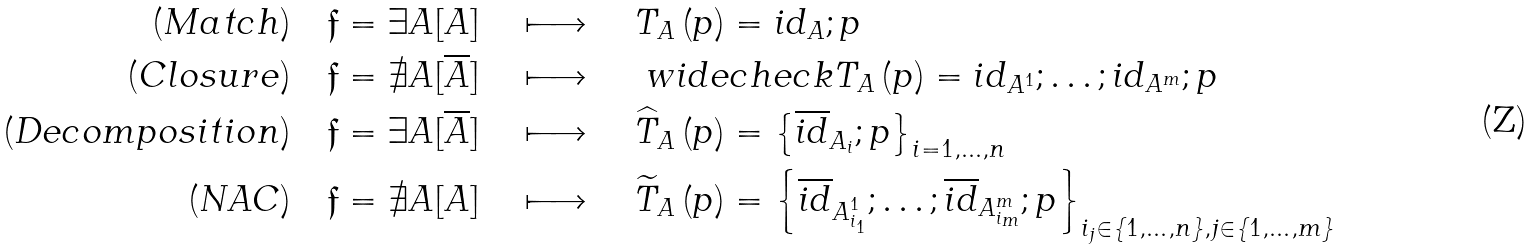<formula> <loc_0><loc_0><loc_500><loc_500>( M a t c h ) \quad \mathfrak { f } & = \exists A [ A ] \quad \longmapsto \quad T _ { A } \left ( p \right ) = i d _ { A } ; p \\ ( C l o s u r e ) \quad \mathfrak { f } & = \nexists A [ \overline { A } ] \quad \longmapsto \quad \ w i d e c h e c k { T } _ { A } \left ( p \right ) = i d _ { A ^ { 1 } } ; \dots ; i d _ { A ^ { m } } ; p \\ ( D e c o m p o s i t i o n ) \quad \mathfrak { f } & = \exists A [ \overline { A } ] \quad \longmapsto \quad \widehat { T } _ { A } \left ( p \right ) = \left \{ \overline { i d } _ { A _ { i } } ; p \right \} _ { i = 1 , \dots , n } \\ ( N A C ) \quad \mathfrak { f } & = \nexists A [ A ] \quad \longmapsto \quad \widetilde { T } _ { A } \left ( p \right ) = \left \{ \overline { i d } _ { A ^ { 1 } _ { i _ { 1 } } } ; \dots ; \overline { i d } _ { A ^ { m } _ { i _ { m } } } ; p \right \} _ { i _ { j } \in \{ 1 , \dots , n \} , j \in \{ 1 , \dots , m \} }</formula> 